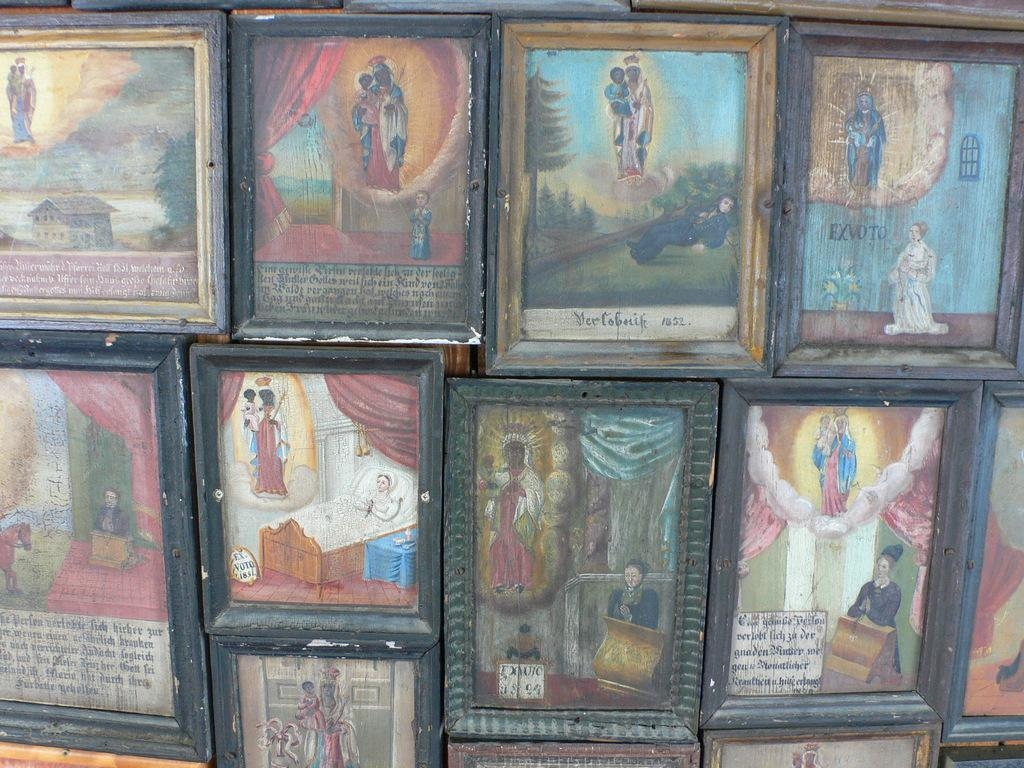<image>
Relay a brief, clear account of the picture shown. Collage of many pictures with one saying the year 1852 on it. 